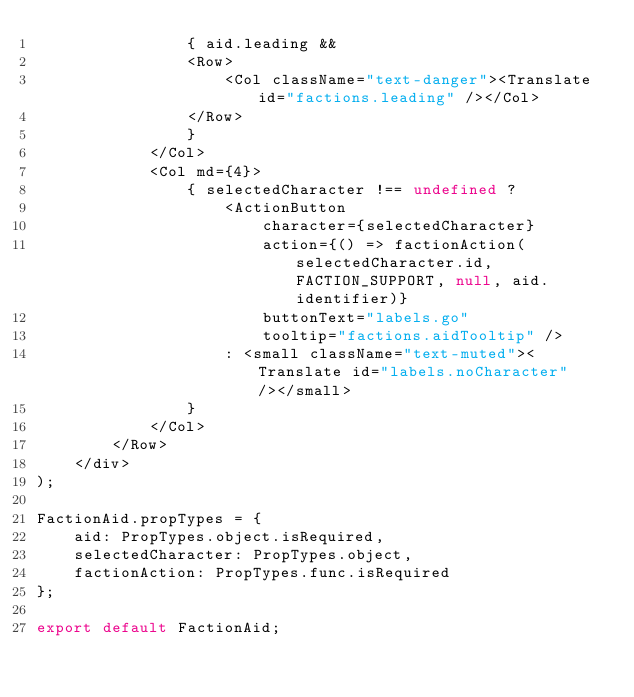Convert code to text. <code><loc_0><loc_0><loc_500><loc_500><_JavaScript_>                { aid.leading &&
                <Row>
                    <Col className="text-danger"><Translate id="factions.leading" /></Col>
                </Row>
                }
            </Col>
            <Col md={4}>
                { selectedCharacter !== undefined ?
                    <ActionButton
                        character={selectedCharacter}
                        action={() => factionAction(selectedCharacter.id, FACTION_SUPPORT, null, aid.identifier)}
                        buttonText="labels.go"
                        tooltip="factions.aidTooltip" />
                    : <small className="text-muted"><Translate id="labels.noCharacter" /></small>
                }
            </Col>
        </Row>
    </div>
);

FactionAid.propTypes = {
    aid: PropTypes.object.isRequired,
    selectedCharacter: PropTypes.object,
    factionAction: PropTypes.func.isRequired
};

export default FactionAid;</code> 